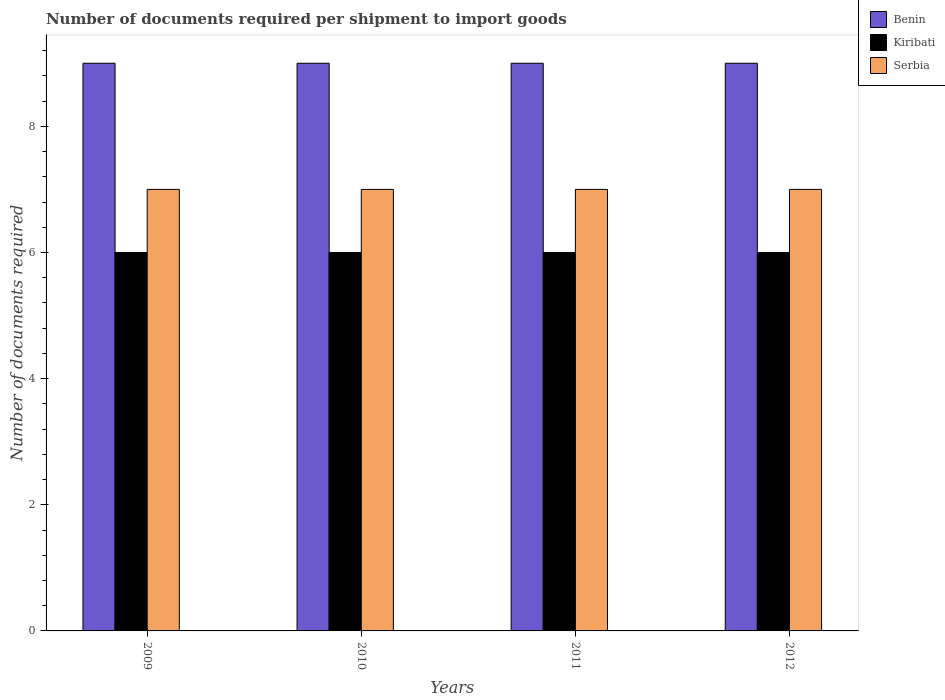How many different coloured bars are there?
Offer a terse response. 3. Are the number of bars on each tick of the X-axis equal?
Offer a very short reply. Yes. How many bars are there on the 1st tick from the left?
Your answer should be very brief. 3. How many bars are there on the 4th tick from the right?
Your answer should be compact. 3. What is the label of the 2nd group of bars from the left?
Make the answer very short. 2010. Across all years, what is the maximum number of documents required per shipment to import goods in Serbia?
Your response must be concise. 7. Across all years, what is the minimum number of documents required per shipment to import goods in Serbia?
Keep it short and to the point. 7. In which year was the number of documents required per shipment to import goods in Kiribati maximum?
Keep it short and to the point. 2009. In which year was the number of documents required per shipment to import goods in Serbia minimum?
Offer a terse response. 2009. What is the total number of documents required per shipment to import goods in Benin in the graph?
Keep it short and to the point. 36. What is the difference between the number of documents required per shipment to import goods in Serbia in 2010 and the number of documents required per shipment to import goods in Benin in 2009?
Ensure brevity in your answer.  -2. What is the average number of documents required per shipment to import goods in Benin per year?
Your answer should be very brief. 9. In the year 2009, what is the difference between the number of documents required per shipment to import goods in Serbia and number of documents required per shipment to import goods in Benin?
Provide a succinct answer. -2. What is the ratio of the number of documents required per shipment to import goods in Serbia in 2009 to that in 2012?
Provide a succinct answer. 1. Is the number of documents required per shipment to import goods in Benin in 2009 less than that in 2012?
Provide a short and direct response. No. In how many years, is the number of documents required per shipment to import goods in Kiribati greater than the average number of documents required per shipment to import goods in Kiribati taken over all years?
Your answer should be compact. 0. What does the 2nd bar from the left in 2010 represents?
Give a very brief answer. Kiribati. What does the 3rd bar from the right in 2011 represents?
Offer a terse response. Benin. Are all the bars in the graph horizontal?
Your answer should be very brief. No. What is the difference between two consecutive major ticks on the Y-axis?
Give a very brief answer. 2. Where does the legend appear in the graph?
Your answer should be compact. Top right. How many legend labels are there?
Give a very brief answer. 3. How are the legend labels stacked?
Offer a very short reply. Vertical. What is the title of the graph?
Make the answer very short. Number of documents required per shipment to import goods. Does "India" appear as one of the legend labels in the graph?
Provide a succinct answer. No. What is the label or title of the X-axis?
Make the answer very short. Years. What is the label or title of the Y-axis?
Provide a succinct answer. Number of documents required. What is the Number of documents required in Serbia in 2009?
Your answer should be very brief. 7. What is the Number of documents required in Benin in 2010?
Your answer should be compact. 9. What is the Number of documents required of Serbia in 2010?
Your answer should be very brief. 7. What is the Number of documents required in Benin in 2011?
Keep it short and to the point. 9. What is the Number of documents required in Kiribati in 2011?
Ensure brevity in your answer.  6. What is the Number of documents required in Serbia in 2011?
Give a very brief answer. 7. What is the Number of documents required of Kiribati in 2012?
Ensure brevity in your answer.  6. What is the Number of documents required of Serbia in 2012?
Provide a short and direct response. 7. Across all years, what is the maximum Number of documents required in Benin?
Offer a very short reply. 9. Across all years, what is the maximum Number of documents required of Serbia?
Your answer should be compact. 7. Across all years, what is the minimum Number of documents required of Benin?
Make the answer very short. 9. Across all years, what is the minimum Number of documents required in Serbia?
Offer a terse response. 7. What is the total Number of documents required of Benin in the graph?
Offer a very short reply. 36. What is the total Number of documents required in Kiribati in the graph?
Ensure brevity in your answer.  24. What is the difference between the Number of documents required of Kiribati in 2009 and that in 2010?
Keep it short and to the point. 0. What is the difference between the Number of documents required in Serbia in 2009 and that in 2010?
Make the answer very short. 0. What is the difference between the Number of documents required of Kiribati in 2009 and that in 2011?
Make the answer very short. 0. What is the difference between the Number of documents required in Serbia in 2009 and that in 2011?
Provide a succinct answer. 0. What is the difference between the Number of documents required of Kiribati in 2009 and that in 2012?
Offer a terse response. 0. What is the difference between the Number of documents required in Kiribati in 2010 and that in 2011?
Offer a terse response. 0. What is the difference between the Number of documents required of Serbia in 2010 and that in 2011?
Your answer should be compact. 0. What is the difference between the Number of documents required of Serbia in 2011 and that in 2012?
Offer a very short reply. 0. What is the difference between the Number of documents required of Benin in 2009 and the Number of documents required of Kiribati in 2010?
Your response must be concise. 3. What is the difference between the Number of documents required of Benin in 2009 and the Number of documents required of Serbia in 2010?
Offer a very short reply. 2. What is the difference between the Number of documents required of Benin in 2009 and the Number of documents required of Serbia in 2011?
Make the answer very short. 2. What is the difference between the Number of documents required in Kiribati in 2009 and the Number of documents required in Serbia in 2011?
Provide a succinct answer. -1. What is the difference between the Number of documents required in Benin in 2009 and the Number of documents required in Kiribati in 2012?
Make the answer very short. 3. What is the difference between the Number of documents required in Benin in 2010 and the Number of documents required in Serbia in 2011?
Provide a succinct answer. 2. What is the difference between the Number of documents required of Benin in 2011 and the Number of documents required of Kiribati in 2012?
Keep it short and to the point. 3. What is the average Number of documents required of Benin per year?
Your answer should be compact. 9. What is the average Number of documents required in Serbia per year?
Your answer should be compact. 7. In the year 2009, what is the difference between the Number of documents required of Benin and Number of documents required of Serbia?
Provide a succinct answer. 2. In the year 2009, what is the difference between the Number of documents required of Kiribati and Number of documents required of Serbia?
Your answer should be compact. -1. In the year 2010, what is the difference between the Number of documents required of Kiribati and Number of documents required of Serbia?
Offer a terse response. -1. In the year 2011, what is the difference between the Number of documents required of Benin and Number of documents required of Kiribati?
Make the answer very short. 3. In the year 2012, what is the difference between the Number of documents required of Benin and Number of documents required of Serbia?
Give a very brief answer. 2. In the year 2012, what is the difference between the Number of documents required in Kiribati and Number of documents required in Serbia?
Make the answer very short. -1. What is the ratio of the Number of documents required in Benin in 2009 to that in 2010?
Ensure brevity in your answer.  1. What is the ratio of the Number of documents required in Kiribati in 2009 to that in 2011?
Provide a short and direct response. 1. What is the ratio of the Number of documents required of Benin in 2009 to that in 2012?
Provide a succinct answer. 1. What is the ratio of the Number of documents required of Kiribati in 2009 to that in 2012?
Give a very brief answer. 1. What is the ratio of the Number of documents required in Benin in 2010 to that in 2011?
Provide a short and direct response. 1. What is the ratio of the Number of documents required in Kiribati in 2010 to that in 2011?
Give a very brief answer. 1. What is the ratio of the Number of documents required of Serbia in 2010 to that in 2011?
Keep it short and to the point. 1. What is the ratio of the Number of documents required in Serbia in 2010 to that in 2012?
Keep it short and to the point. 1. What is the difference between the highest and the second highest Number of documents required in Benin?
Offer a very short reply. 0. What is the difference between the highest and the second highest Number of documents required of Kiribati?
Provide a short and direct response. 0. What is the difference between the highest and the second highest Number of documents required of Serbia?
Your answer should be compact. 0. 